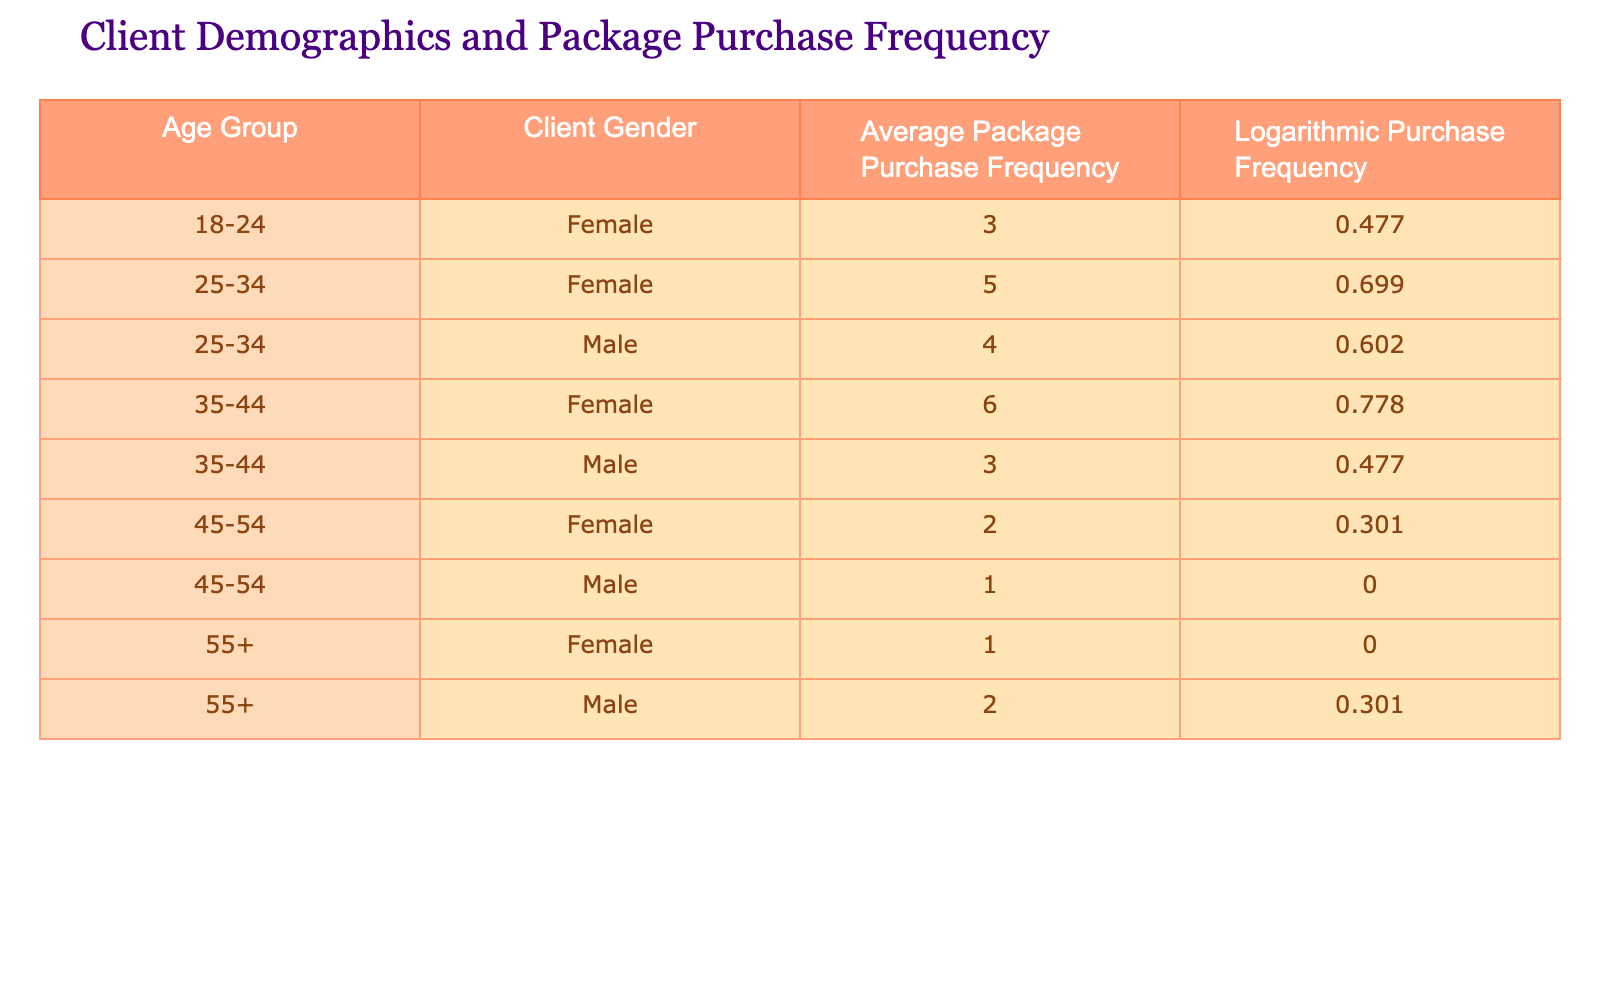What is the purchase frequency of females in the age group 35-44? From the table, we look for the row where the Age Group is "35-44" and the Client Gender is "Female", which shows an Average Package Purchase Frequency of 6.
Answer: 6 What is the logarithmic purchase frequency for males aged 25-34? By locating the row with Age Group "25-34" and Client Gender "Male", we find that the Logarithmic Purchase Frequency is 0.602.
Answer: 0.602 How many clients in the age group 45-54 completely stopped purchasing packages? We check the Age Group "45-54" and find that the Male frequency is 1 and Female frequency is 2. Only the Male has a frequency of 0, indicating he has stopped purchasing. Thus, the answer is 1.
Answer: 1 Which age group has the highest average package purchase frequency? By scanning through the Average Package Purchase Frequency column, we compare all values. The highest frequency is 6 for the age group 35-44 (Female).
Answer: 35-44 What is the combined average package purchase frequency for all males? We identify the Average Package Purchase Frequency for all males: 4 (25-34) + 3 (35-44) + 1 (45-54) + 2 (55+). This sums to 10, and there are 4 males, resulting in an average of 10/4 = 2.5.
Answer: 2.5 Is the average package purchase frequency for females higher than that of males in the 25-34 age group? The Average Package Purchase Frequency for females in the same age group is 5, while for males, it is 4. Because 5 is greater than 4, the answer is yes.
Answer: Yes What percentage of clients aged 55 and older purchase packages at least once? We see that in the age group 55+, there are 2 clients: 1 female (who purchased once) and 1 male (who purchased 2). Since both clients have a purchase frequency greater than 0, the percentage of clients who purchased is 100%.
Answer: 100% What is the difference in logarithmic purchase frequency between the age groups 18-24 and 45-54 for females? The Logarithmic Purchase Frequency for females aged 18-24 is 0.477, and for 45-54, it's 0.301. The difference is calculated: 0.477 - 0.301 = 0.176.
Answer: 0.176 Is there any male client aged 55 and older with an average package purchase frequency greater than 1? Checking the data, the male client in the 55+ age group has a frequency of 2, which is greater than 1. Therefore, the answer is yes.
Answer: Yes 